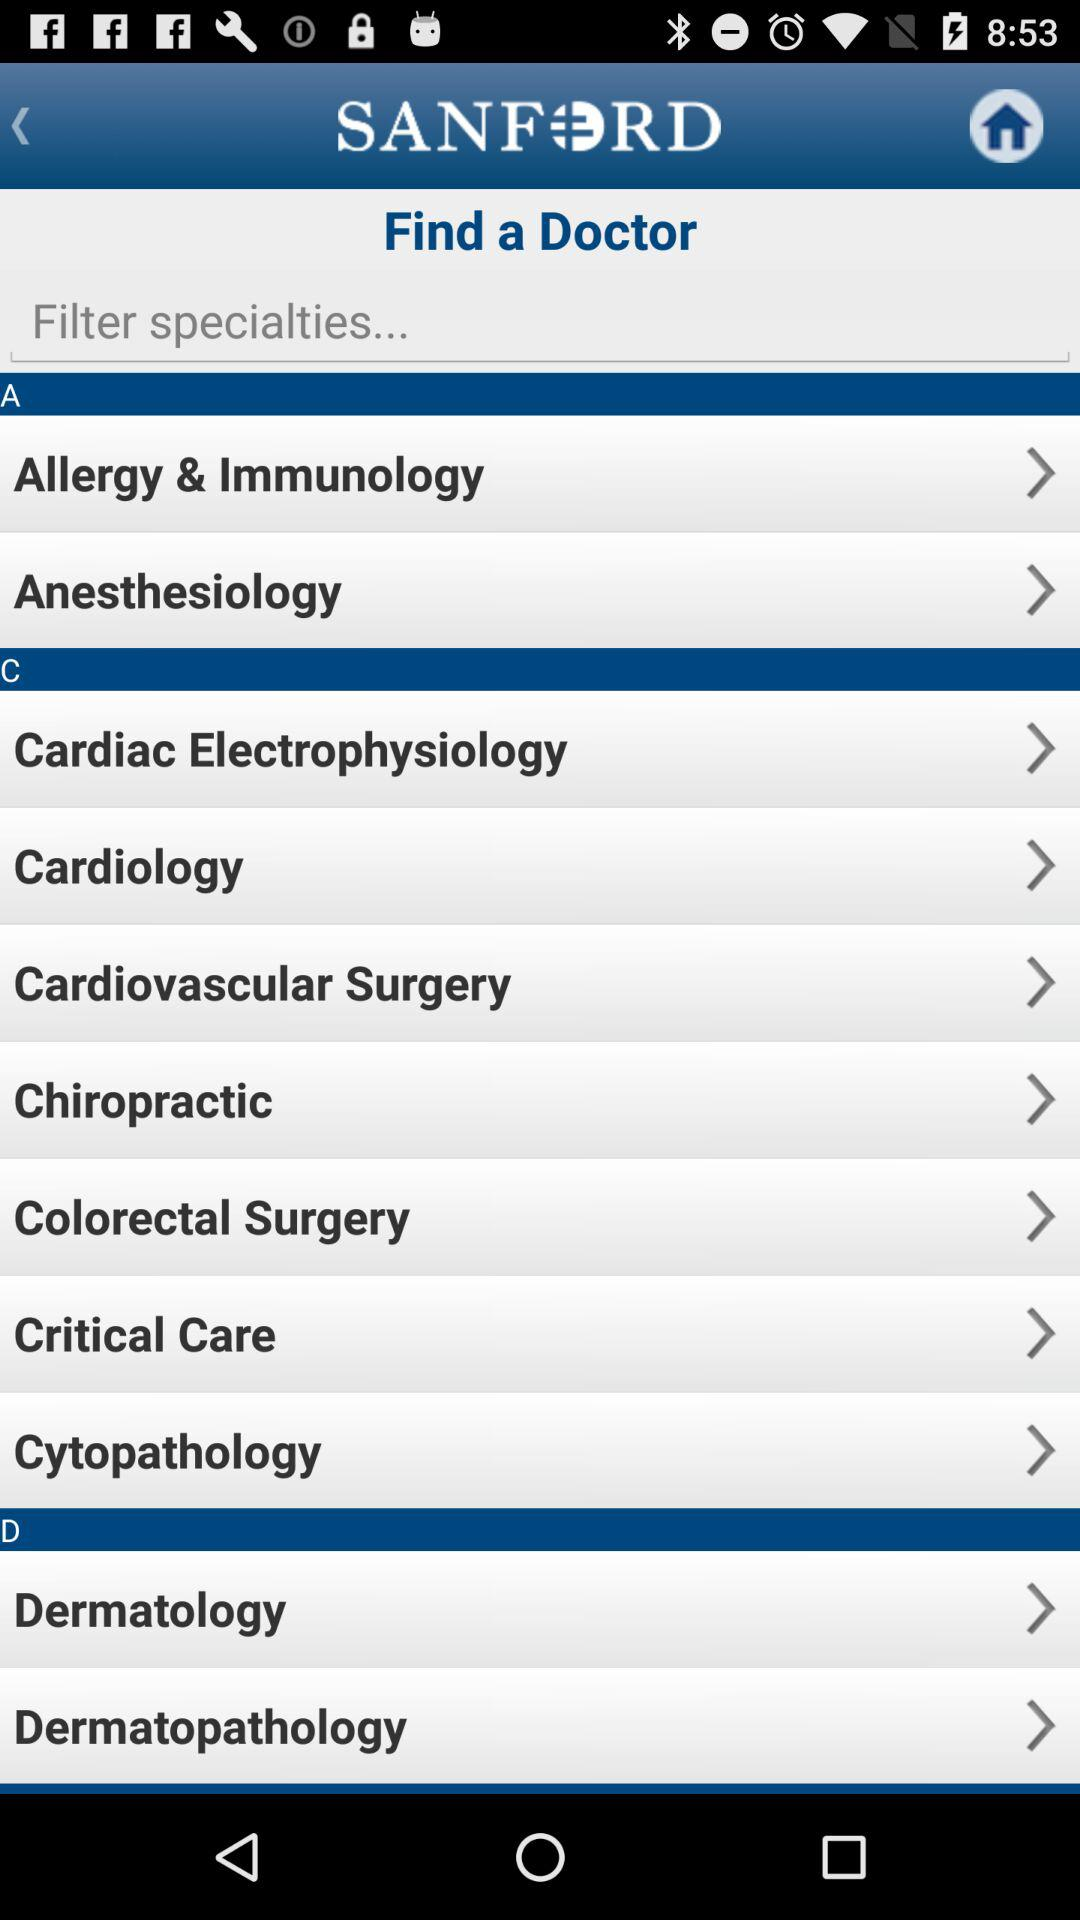What is the application name? The application name is "SANFORD". 